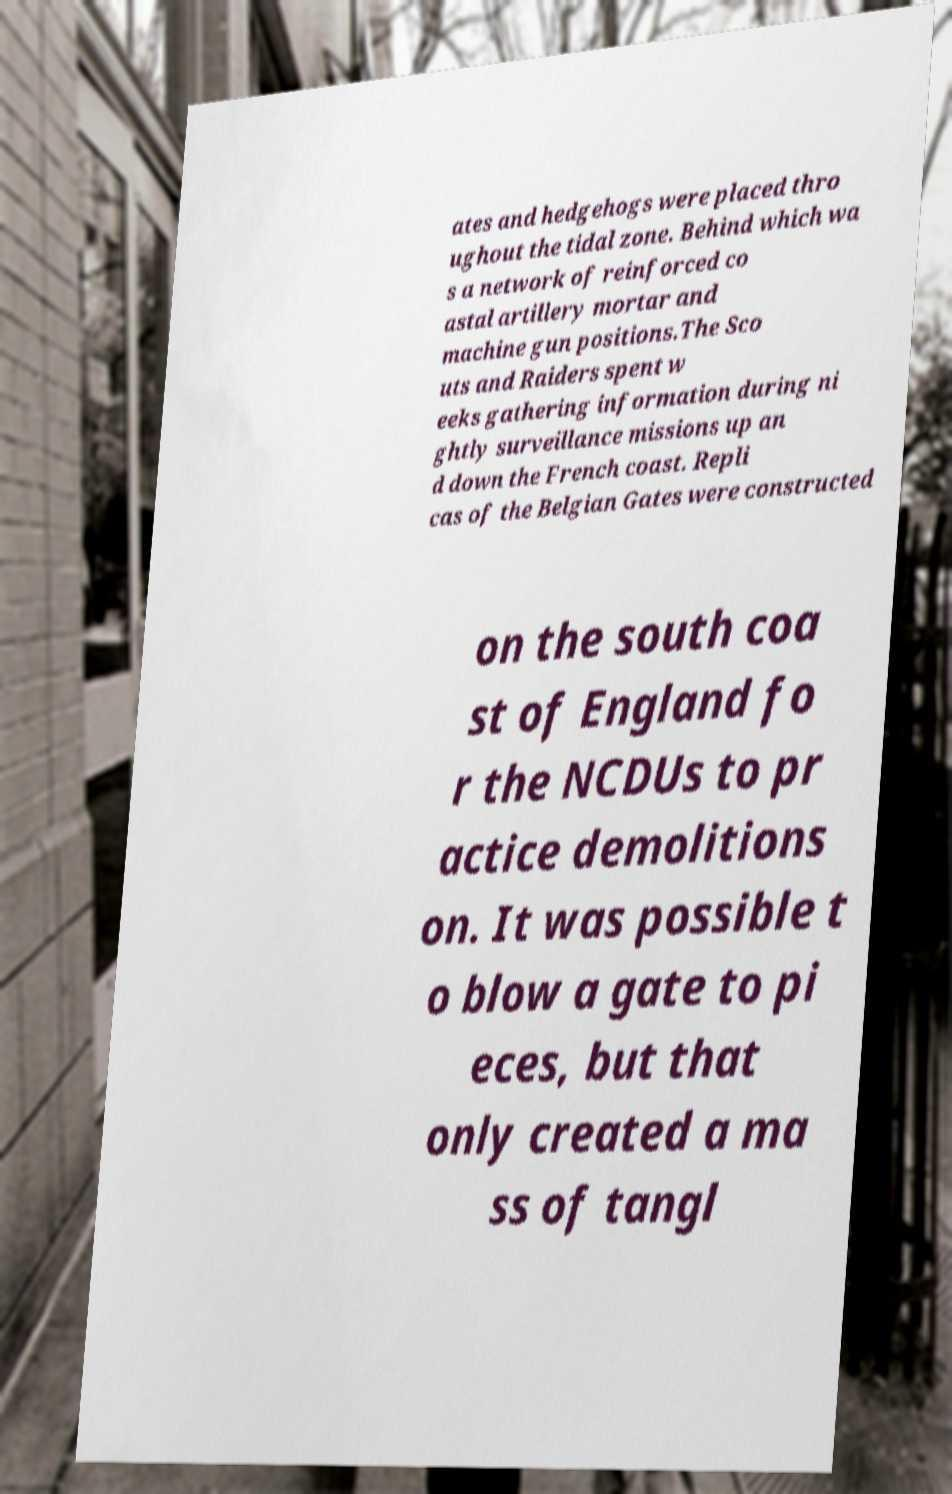Please read and relay the text visible in this image. What does it say? ates and hedgehogs were placed thro ughout the tidal zone. Behind which wa s a network of reinforced co astal artillery mortar and machine gun positions.The Sco uts and Raiders spent w eeks gathering information during ni ghtly surveillance missions up an d down the French coast. Repli cas of the Belgian Gates were constructed on the south coa st of England fo r the NCDUs to pr actice demolitions on. It was possible t o blow a gate to pi eces, but that only created a ma ss of tangl 